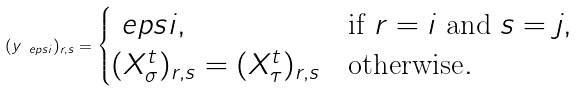<formula> <loc_0><loc_0><loc_500><loc_500>( y _ { \ e p s i } ) _ { r , s } = \begin{cases} \ e p s i , & \text {if } r = i \text { and } s = j , \\ ( X _ { \sigma } ^ { t } ) _ { r , s } = ( X _ { \tau } ^ { t } ) _ { r , s } & \text {otherwise} . \end{cases}</formula> 